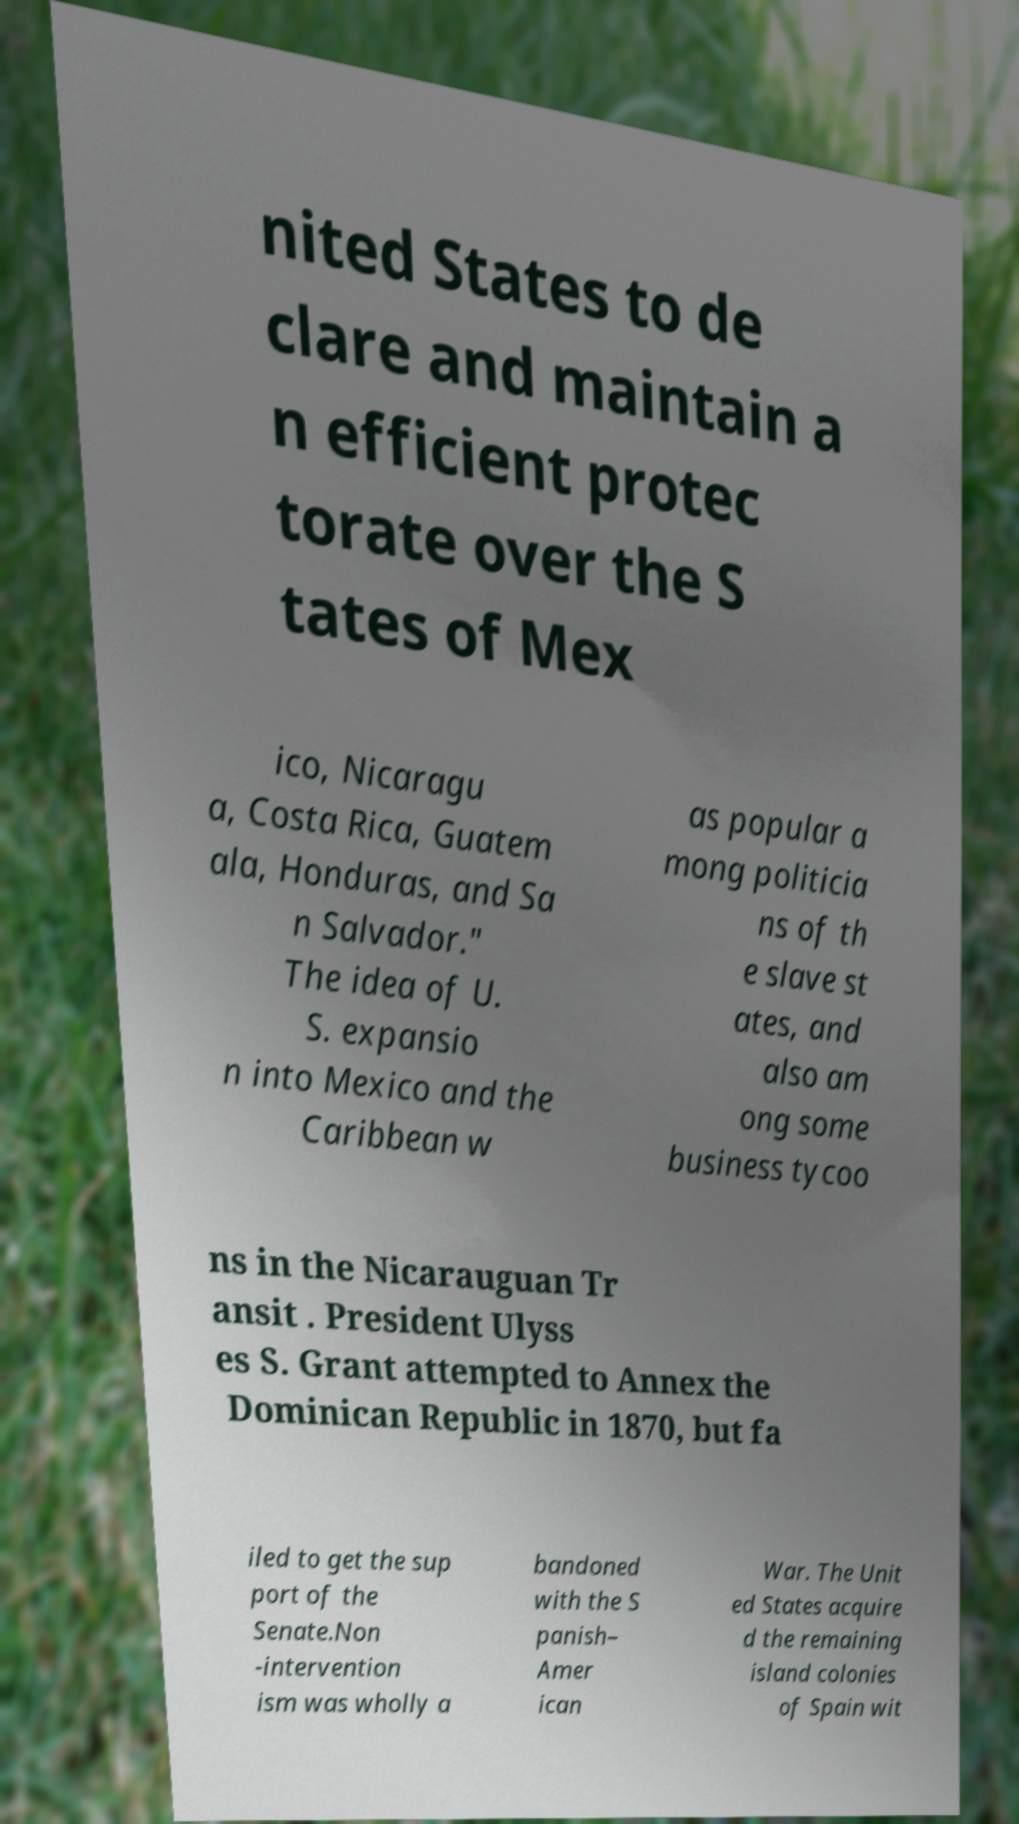What messages or text are displayed in this image? I need them in a readable, typed format. nited States to de clare and maintain a n efficient protec torate over the S tates of Mex ico, Nicaragu a, Costa Rica, Guatem ala, Honduras, and Sa n Salvador." The idea of U. S. expansio n into Mexico and the Caribbean w as popular a mong politicia ns of th e slave st ates, and also am ong some business tycoo ns in the Nicarauguan Tr ansit . President Ulyss es S. Grant attempted to Annex the Dominican Republic in 1870, but fa iled to get the sup port of the Senate.Non -intervention ism was wholly a bandoned with the S panish– Amer ican War. The Unit ed States acquire d the remaining island colonies of Spain wit 